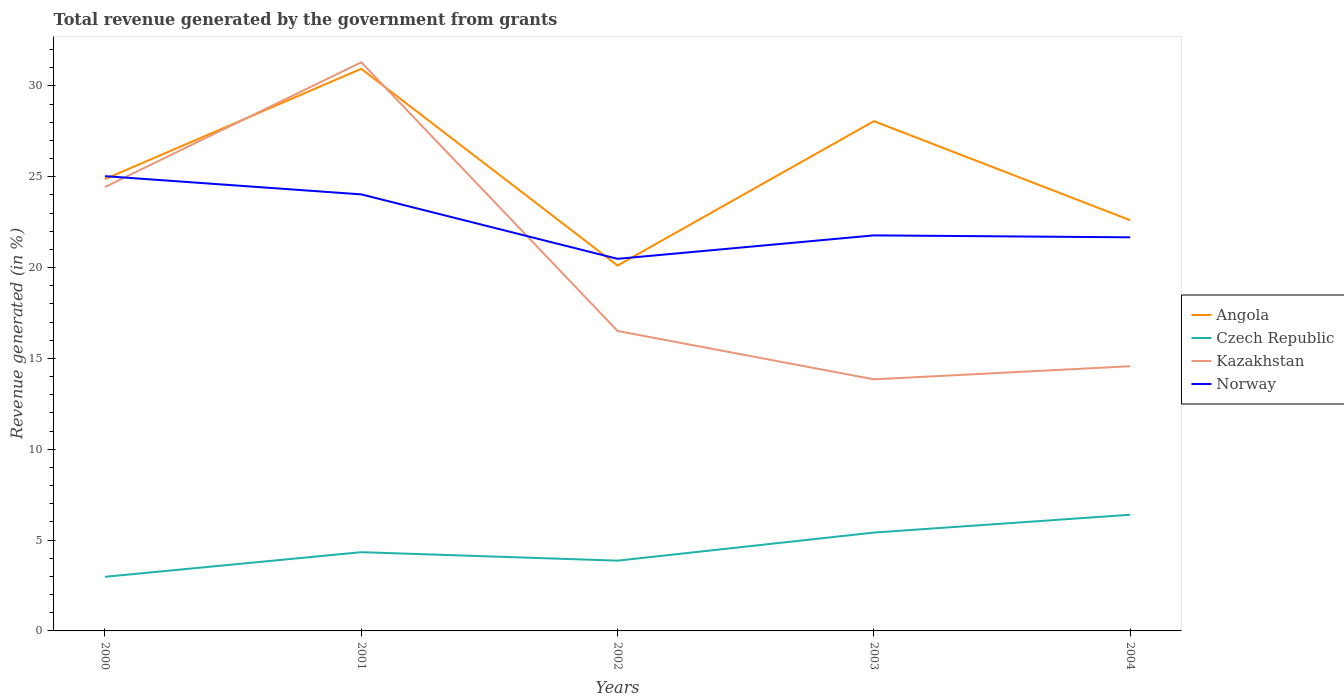How many different coloured lines are there?
Offer a terse response. 4. Does the line corresponding to Kazakhstan intersect with the line corresponding to Norway?
Offer a terse response. Yes. Across all years, what is the maximum total revenue generated in Czech Republic?
Your response must be concise. 2.98. What is the total total revenue generated in Norway in the graph?
Your answer should be compact. 2.26. What is the difference between the highest and the second highest total revenue generated in Czech Republic?
Keep it short and to the point. 3.41. Is the total revenue generated in Kazakhstan strictly greater than the total revenue generated in Angola over the years?
Provide a short and direct response. No. How many years are there in the graph?
Offer a very short reply. 5. Are the values on the major ticks of Y-axis written in scientific E-notation?
Your answer should be very brief. No. Does the graph contain any zero values?
Give a very brief answer. No. Does the graph contain grids?
Offer a terse response. No. How are the legend labels stacked?
Offer a terse response. Vertical. What is the title of the graph?
Your answer should be compact. Total revenue generated by the government from grants. Does "Iceland" appear as one of the legend labels in the graph?
Provide a short and direct response. No. What is the label or title of the Y-axis?
Provide a short and direct response. Revenue generated (in %). What is the Revenue generated (in %) in Angola in 2000?
Provide a succinct answer. 24.87. What is the Revenue generated (in %) of Czech Republic in 2000?
Give a very brief answer. 2.98. What is the Revenue generated (in %) of Kazakhstan in 2000?
Your answer should be compact. 24.43. What is the Revenue generated (in %) of Norway in 2000?
Keep it short and to the point. 25.03. What is the Revenue generated (in %) of Angola in 2001?
Your answer should be compact. 30.94. What is the Revenue generated (in %) of Czech Republic in 2001?
Make the answer very short. 4.33. What is the Revenue generated (in %) of Kazakhstan in 2001?
Ensure brevity in your answer.  31.3. What is the Revenue generated (in %) of Norway in 2001?
Your answer should be compact. 24.03. What is the Revenue generated (in %) of Angola in 2002?
Your answer should be very brief. 20.11. What is the Revenue generated (in %) of Czech Republic in 2002?
Offer a very short reply. 3.87. What is the Revenue generated (in %) in Kazakhstan in 2002?
Provide a short and direct response. 16.51. What is the Revenue generated (in %) in Norway in 2002?
Your answer should be compact. 20.48. What is the Revenue generated (in %) in Angola in 2003?
Provide a short and direct response. 28.06. What is the Revenue generated (in %) of Czech Republic in 2003?
Give a very brief answer. 5.41. What is the Revenue generated (in %) of Kazakhstan in 2003?
Make the answer very short. 13.85. What is the Revenue generated (in %) in Norway in 2003?
Keep it short and to the point. 21.77. What is the Revenue generated (in %) in Angola in 2004?
Provide a short and direct response. 22.61. What is the Revenue generated (in %) of Czech Republic in 2004?
Provide a succinct answer. 6.39. What is the Revenue generated (in %) in Kazakhstan in 2004?
Offer a very short reply. 14.57. What is the Revenue generated (in %) in Norway in 2004?
Provide a short and direct response. 21.66. Across all years, what is the maximum Revenue generated (in %) of Angola?
Provide a succinct answer. 30.94. Across all years, what is the maximum Revenue generated (in %) of Czech Republic?
Provide a short and direct response. 6.39. Across all years, what is the maximum Revenue generated (in %) of Kazakhstan?
Provide a succinct answer. 31.3. Across all years, what is the maximum Revenue generated (in %) in Norway?
Your answer should be very brief. 25.03. Across all years, what is the minimum Revenue generated (in %) in Angola?
Give a very brief answer. 20.11. Across all years, what is the minimum Revenue generated (in %) of Czech Republic?
Keep it short and to the point. 2.98. Across all years, what is the minimum Revenue generated (in %) of Kazakhstan?
Offer a terse response. 13.85. Across all years, what is the minimum Revenue generated (in %) of Norway?
Provide a short and direct response. 20.48. What is the total Revenue generated (in %) in Angola in the graph?
Make the answer very short. 126.58. What is the total Revenue generated (in %) in Czech Republic in the graph?
Your answer should be compact. 22.99. What is the total Revenue generated (in %) in Kazakhstan in the graph?
Your response must be concise. 100.65. What is the total Revenue generated (in %) in Norway in the graph?
Offer a terse response. 112.97. What is the difference between the Revenue generated (in %) of Angola in 2000 and that in 2001?
Give a very brief answer. -6.07. What is the difference between the Revenue generated (in %) in Czech Republic in 2000 and that in 2001?
Offer a very short reply. -1.36. What is the difference between the Revenue generated (in %) in Kazakhstan in 2000 and that in 2001?
Provide a short and direct response. -6.87. What is the difference between the Revenue generated (in %) of Norway in 2000 and that in 2001?
Offer a very short reply. 1. What is the difference between the Revenue generated (in %) in Angola in 2000 and that in 2002?
Ensure brevity in your answer.  4.76. What is the difference between the Revenue generated (in %) of Czech Republic in 2000 and that in 2002?
Ensure brevity in your answer.  -0.89. What is the difference between the Revenue generated (in %) of Kazakhstan in 2000 and that in 2002?
Offer a terse response. 7.92. What is the difference between the Revenue generated (in %) in Norway in 2000 and that in 2002?
Your answer should be very brief. 4.55. What is the difference between the Revenue generated (in %) of Angola in 2000 and that in 2003?
Provide a succinct answer. -3.19. What is the difference between the Revenue generated (in %) in Czech Republic in 2000 and that in 2003?
Keep it short and to the point. -2.43. What is the difference between the Revenue generated (in %) in Kazakhstan in 2000 and that in 2003?
Your response must be concise. 10.58. What is the difference between the Revenue generated (in %) of Norway in 2000 and that in 2003?
Your answer should be very brief. 3.26. What is the difference between the Revenue generated (in %) of Angola in 2000 and that in 2004?
Offer a terse response. 2.26. What is the difference between the Revenue generated (in %) in Czech Republic in 2000 and that in 2004?
Give a very brief answer. -3.41. What is the difference between the Revenue generated (in %) in Kazakhstan in 2000 and that in 2004?
Your answer should be compact. 9.86. What is the difference between the Revenue generated (in %) in Norway in 2000 and that in 2004?
Offer a very short reply. 3.37. What is the difference between the Revenue generated (in %) of Angola in 2001 and that in 2002?
Ensure brevity in your answer.  10.83. What is the difference between the Revenue generated (in %) of Czech Republic in 2001 and that in 2002?
Offer a very short reply. 0.47. What is the difference between the Revenue generated (in %) in Kazakhstan in 2001 and that in 2002?
Provide a succinct answer. 14.79. What is the difference between the Revenue generated (in %) in Norway in 2001 and that in 2002?
Give a very brief answer. 3.55. What is the difference between the Revenue generated (in %) in Angola in 2001 and that in 2003?
Offer a terse response. 2.88. What is the difference between the Revenue generated (in %) of Czech Republic in 2001 and that in 2003?
Make the answer very short. -1.08. What is the difference between the Revenue generated (in %) of Kazakhstan in 2001 and that in 2003?
Provide a succinct answer. 17.45. What is the difference between the Revenue generated (in %) in Norway in 2001 and that in 2003?
Your response must be concise. 2.26. What is the difference between the Revenue generated (in %) in Angola in 2001 and that in 2004?
Offer a very short reply. 8.33. What is the difference between the Revenue generated (in %) of Czech Republic in 2001 and that in 2004?
Your answer should be compact. -2.06. What is the difference between the Revenue generated (in %) of Kazakhstan in 2001 and that in 2004?
Your response must be concise. 16.73. What is the difference between the Revenue generated (in %) in Norway in 2001 and that in 2004?
Your response must be concise. 2.36. What is the difference between the Revenue generated (in %) in Angola in 2002 and that in 2003?
Ensure brevity in your answer.  -7.95. What is the difference between the Revenue generated (in %) in Czech Republic in 2002 and that in 2003?
Your answer should be compact. -1.55. What is the difference between the Revenue generated (in %) of Kazakhstan in 2002 and that in 2003?
Your response must be concise. 2.66. What is the difference between the Revenue generated (in %) in Norway in 2002 and that in 2003?
Provide a short and direct response. -1.29. What is the difference between the Revenue generated (in %) in Angola in 2002 and that in 2004?
Offer a very short reply. -2.5. What is the difference between the Revenue generated (in %) in Czech Republic in 2002 and that in 2004?
Make the answer very short. -2.53. What is the difference between the Revenue generated (in %) in Kazakhstan in 2002 and that in 2004?
Make the answer very short. 1.94. What is the difference between the Revenue generated (in %) of Norway in 2002 and that in 2004?
Offer a terse response. -1.18. What is the difference between the Revenue generated (in %) in Angola in 2003 and that in 2004?
Offer a very short reply. 5.45. What is the difference between the Revenue generated (in %) in Czech Republic in 2003 and that in 2004?
Keep it short and to the point. -0.98. What is the difference between the Revenue generated (in %) of Kazakhstan in 2003 and that in 2004?
Give a very brief answer. -0.72. What is the difference between the Revenue generated (in %) in Norway in 2003 and that in 2004?
Make the answer very short. 0.11. What is the difference between the Revenue generated (in %) of Angola in 2000 and the Revenue generated (in %) of Czech Republic in 2001?
Make the answer very short. 20.53. What is the difference between the Revenue generated (in %) in Angola in 2000 and the Revenue generated (in %) in Kazakhstan in 2001?
Provide a succinct answer. -6.43. What is the difference between the Revenue generated (in %) of Angola in 2000 and the Revenue generated (in %) of Norway in 2001?
Offer a terse response. 0.84. What is the difference between the Revenue generated (in %) in Czech Republic in 2000 and the Revenue generated (in %) in Kazakhstan in 2001?
Your response must be concise. -28.32. What is the difference between the Revenue generated (in %) of Czech Republic in 2000 and the Revenue generated (in %) of Norway in 2001?
Offer a very short reply. -21.05. What is the difference between the Revenue generated (in %) in Kazakhstan in 2000 and the Revenue generated (in %) in Norway in 2001?
Provide a succinct answer. 0.4. What is the difference between the Revenue generated (in %) of Angola in 2000 and the Revenue generated (in %) of Czech Republic in 2002?
Your response must be concise. 21. What is the difference between the Revenue generated (in %) in Angola in 2000 and the Revenue generated (in %) in Kazakhstan in 2002?
Provide a short and direct response. 8.36. What is the difference between the Revenue generated (in %) of Angola in 2000 and the Revenue generated (in %) of Norway in 2002?
Keep it short and to the point. 4.39. What is the difference between the Revenue generated (in %) in Czech Republic in 2000 and the Revenue generated (in %) in Kazakhstan in 2002?
Offer a very short reply. -13.53. What is the difference between the Revenue generated (in %) in Czech Republic in 2000 and the Revenue generated (in %) in Norway in 2002?
Provide a succinct answer. -17.5. What is the difference between the Revenue generated (in %) of Kazakhstan in 2000 and the Revenue generated (in %) of Norway in 2002?
Offer a very short reply. 3.95. What is the difference between the Revenue generated (in %) of Angola in 2000 and the Revenue generated (in %) of Czech Republic in 2003?
Your response must be concise. 19.46. What is the difference between the Revenue generated (in %) in Angola in 2000 and the Revenue generated (in %) in Kazakhstan in 2003?
Your answer should be very brief. 11.02. What is the difference between the Revenue generated (in %) of Angola in 2000 and the Revenue generated (in %) of Norway in 2003?
Offer a terse response. 3.1. What is the difference between the Revenue generated (in %) of Czech Republic in 2000 and the Revenue generated (in %) of Kazakhstan in 2003?
Your response must be concise. -10.87. What is the difference between the Revenue generated (in %) of Czech Republic in 2000 and the Revenue generated (in %) of Norway in 2003?
Offer a terse response. -18.79. What is the difference between the Revenue generated (in %) in Kazakhstan in 2000 and the Revenue generated (in %) in Norway in 2003?
Provide a short and direct response. 2.66. What is the difference between the Revenue generated (in %) in Angola in 2000 and the Revenue generated (in %) in Czech Republic in 2004?
Offer a very short reply. 18.48. What is the difference between the Revenue generated (in %) of Angola in 2000 and the Revenue generated (in %) of Kazakhstan in 2004?
Offer a terse response. 10.3. What is the difference between the Revenue generated (in %) of Angola in 2000 and the Revenue generated (in %) of Norway in 2004?
Your response must be concise. 3.21. What is the difference between the Revenue generated (in %) in Czech Republic in 2000 and the Revenue generated (in %) in Kazakhstan in 2004?
Make the answer very short. -11.59. What is the difference between the Revenue generated (in %) in Czech Republic in 2000 and the Revenue generated (in %) in Norway in 2004?
Make the answer very short. -18.68. What is the difference between the Revenue generated (in %) of Kazakhstan in 2000 and the Revenue generated (in %) of Norway in 2004?
Provide a succinct answer. 2.77. What is the difference between the Revenue generated (in %) in Angola in 2001 and the Revenue generated (in %) in Czech Republic in 2002?
Your answer should be compact. 27.07. What is the difference between the Revenue generated (in %) in Angola in 2001 and the Revenue generated (in %) in Kazakhstan in 2002?
Offer a terse response. 14.43. What is the difference between the Revenue generated (in %) in Angola in 2001 and the Revenue generated (in %) in Norway in 2002?
Your answer should be very brief. 10.46. What is the difference between the Revenue generated (in %) in Czech Republic in 2001 and the Revenue generated (in %) in Kazakhstan in 2002?
Offer a very short reply. -12.17. What is the difference between the Revenue generated (in %) in Czech Republic in 2001 and the Revenue generated (in %) in Norway in 2002?
Ensure brevity in your answer.  -16.14. What is the difference between the Revenue generated (in %) of Kazakhstan in 2001 and the Revenue generated (in %) of Norway in 2002?
Provide a short and direct response. 10.82. What is the difference between the Revenue generated (in %) of Angola in 2001 and the Revenue generated (in %) of Czech Republic in 2003?
Your answer should be very brief. 25.52. What is the difference between the Revenue generated (in %) of Angola in 2001 and the Revenue generated (in %) of Kazakhstan in 2003?
Provide a succinct answer. 17.09. What is the difference between the Revenue generated (in %) in Angola in 2001 and the Revenue generated (in %) in Norway in 2003?
Provide a short and direct response. 9.17. What is the difference between the Revenue generated (in %) in Czech Republic in 2001 and the Revenue generated (in %) in Kazakhstan in 2003?
Ensure brevity in your answer.  -9.51. What is the difference between the Revenue generated (in %) in Czech Republic in 2001 and the Revenue generated (in %) in Norway in 2003?
Your response must be concise. -17.44. What is the difference between the Revenue generated (in %) in Kazakhstan in 2001 and the Revenue generated (in %) in Norway in 2003?
Provide a short and direct response. 9.53. What is the difference between the Revenue generated (in %) in Angola in 2001 and the Revenue generated (in %) in Czech Republic in 2004?
Offer a terse response. 24.54. What is the difference between the Revenue generated (in %) in Angola in 2001 and the Revenue generated (in %) in Kazakhstan in 2004?
Provide a succinct answer. 16.37. What is the difference between the Revenue generated (in %) of Angola in 2001 and the Revenue generated (in %) of Norway in 2004?
Your response must be concise. 9.27. What is the difference between the Revenue generated (in %) of Czech Republic in 2001 and the Revenue generated (in %) of Kazakhstan in 2004?
Provide a succinct answer. -10.23. What is the difference between the Revenue generated (in %) in Czech Republic in 2001 and the Revenue generated (in %) in Norway in 2004?
Ensure brevity in your answer.  -17.33. What is the difference between the Revenue generated (in %) of Kazakhstan in 2001 and the Revenue generated (in %) of Norway in 2004?
Ensure brevity in your answer.  9.63. What is the difference between the Revenue generated (in %) in Angola in 2002 and the Revenue generated (in %) in Czech Republic in 2003?
Your answer should be compact. 14.7. What is the difference between the Revenue generated (in %) in Angola in 2002 and the Revenue generated (in %) in Kazakhstan in 2003?
Keep it short and to the point. 6.26. What is the difference between the Revenue generated (in %) of Angola in 2002 and the Revenue generated (in %) of Norway in 2003?
Ensure brevity in your answer.  -1.66. What is the difference between the Revenue generated (in %) in Czech Republic in 2002 and the Revenue generated (in %) in Kazakhstan in 2003?
Offer a terse response. -9.98. What is the difference between the Revenue generated (in %) of Czech Republic in 2002 and the Revenue generated (in %) of Norway in 2003?
Ensure brevity in your answer.  -17.9. What is the difference between the Revenue generated (in %) of Kazakhstan in 2002 and the Revenue generated (in %) of Norway in 2003?
Your response must be concise. -5.26. What is the difference between the Revenue generated (in %) of Angola in 2002 and the Revenue generated (in %) of Czech Republic in 2004?
Offer a terse response. 13.72. What is the difference between the Revenue generated (in %) of Angola in 2002 and the Revenue generated (in %) of Kazakhstan in 2004?
Make the answer very short. 5.54. What is the difference between the Revenue generated (in %) of Angola in 2002 and the Revenue generated (in %) of Norway in 2004?
Keep it short and to the point. -1.55. What is the difference between the Revenue generated (in %) of Czech Republic in 2002 and the Revenue generated (in %) of Kazakhstan in 2004?
Offer a very short reply. -10.7. What is the difference between the Revenue generated (in %) of Czech Republic in 2002 and the Revenue generated (in %) of Norway in 2004?
Offer a very short reply. -17.8. What is the difference between the Revenue generated (in %) in Kazakhstan in 2002 and the Revenue generated (in %) in Norway in 2004?
Provide a succinct answer. -5.16. What is the difference between the Revenue generated (in %) in Angola in 2003 and the Revenue generated (in %) in Czech Republic in 2004?
Make the answer very short. 21.66. What is the difference between the Revenue generated (in %) of Angola in 2003 and the Revenue generated (in %) of Kazakhstan in 2004?
Provide a succinct answer. 13.49. What is the difference between the Revenue generated (in %) of Angola in 2003 and the Revenue generated (in %) of Norway in 2004?
Your response must be concise. 6.39. What is the difference between the Revenue generated (in %) in Czech Republic in 2003 and the Revenue generated (in %) in Kazakhstan in 2004?
Your answer should be very brief. -9.15. What is the difference between the Revenue generated (in %) of Czech Republic in 2003 and the Revenue generated (in %) of Norway in 2004?
Give a very brief answer. -16.25. What is the difference between the Revenue generated (in %) in Kazakhstan in 2003 and the Revenue generated (in %) in Norway in 2004?
Your answer should be very brief. -7.82. What is the average Revenue generated (in %) of Angola per year?
Provide a short and direct response. 25.32. What is the average Revenue generated (in %) of Czech Republic per year?
Your answer should be compact. 4.6. What is the average Revenue generated (in %) of Kazakhstan per year?
Keep it short and to the point. 20.13. What is the average Revenue generated (in %) in Norway per year?
Your answer should be compact. 22.59. In the year 2000, what is the difference between the Revenue generated (in %) of Angola and Revenue generated (in %) of Czech Republic?
Ensure brevity in your answer.  21.89. In the year 2000, what is the difference between the Revenue generated (in %) in Angola and Revenue generated (in %) in Kazakhstan?
Your response must be concise. 0.44. In the year 2000, what is the difference between the Revenue generated (in %) of Angola and Revenue generated (in %) of Norway?
Provide a succinct answer. -0.16. In the year 2000, what is the difference between the Revenue generated (in %) of Czech Republic and Revenue generated (in %) of Kazakhstan?
Ensure brevity in your answer.  -21.45. In the year 2000, what is the difference between the Revenue generated (in %) of Czech Republic and Revenue generated (in %) of Norway?
Give a very brief answer. -22.05. In the year 2000, what is the difference between the Revenue generated (in %) in Kazakhstan and Revenue generated (in %) in Norway?
Provide a succinct answer. -0.6. In the year 2001, what is the difference between the Revenue generated (in %) in Angola and Revenue generated (in %) in Czech Republic?
Offer a very short reply. 26.6. In the year 2001, what is the difference between the Revenue generated (in %) of Angola and Revenue generated (in %) of Kazakhstan?
Keep it short and to the point. -0.36. In the year 2001, what is the difference between the Revenue generated (in %) of Angola and Revenue generated (in %) of Norway?
Give a very brief answer. 6.91. In the year 2001, what is the difference between the Revenue generated (in %) of Czech Republic and Revenue generated (in %) of Kazakhstan?
Offer a very short reply. -26.96. In the year 2001, what is the difference between the Revenue generated (in %) of Czech Republic and Revenue generated (in %) of Norway?
Ensure brevity in your answer.  -19.69. In the year 2001, what is the difference between the Revenue generated (in %) in Kazakhstan and Revenue generated (in %) in Norway?
Ensure brevity in your answer.  7.27. In the year 2002, what is the difference between the Revenue generated (in %) in Angola and Revenue generated (in %) in Czech Republic?
Give a very brief answer. 16.24. In the year 2002, what is the difference between the Revenue generated (in %) of Angola and Revenue generated (in %) of Kazakhstan?
Your response must be concise. 3.6. In the year 2002, what is the difference between the Revenue generated (in %) of Angola and Revenue generated (in %) of Norway?
Keep it short and to the point. -0.37. In the year 2002, what is the difference between the Revenue generated (in %) of Czech Republic and Revenue generated (in %) of Kazakhstan?
Provide a succinct answer. -12.64. In the year 2002, what is the difference between the Revenue generated (in %) of Czech Republic and Revenue generated (in %) of Norway?
Ensure brevity in your answer.  -16.61. In the year 2002, what is the difference between the Revenue generated (in %) of Kazakhstan and Revenue generated (in %) of Norway?
Keep it short and to the point. -3.97. In the year 2003, what is the difference between the Revenue generated (in %) of Angola and Revenue generated (in %) of Czech Republic?
Ensure brevity in your answer.  22.64. In the year 2003, what is the difference between the Revenue generated (in %) of Angola and Revenue generated (in %) of Kazakhstan?
Keep it short and to the point. 14.21. In the year 2003, what is the difference between the Revenue generated (in %) in Angola and Revenue generated (in %) in Norway?
Provide a short and direct response. 6.29. In the year 2003, what is the difference between the Revenue generated (in %) of Czech Republic and Revenue generated (in %) of Kazakhstan?
Offer a terse response. -8.43. In the year 2003, what is the difference between the Revenue generated (in %) of Czech Republic and Revenue generated (in %) of Norway?
Make the answer very short. -16.36. In the year 2003, what is the difference between the Revenue generated (in %) of Kazakhstan and Revenue generated (in %) of Norway?
Offer a terse response. -7.92. In the year 2004, what is the difference between the Revenue generated (in %) of Angola and Revenue generated (in %) of Czech Republic?
Offer a terse response. 16.21. In the year 2004, what is the difference between the Revenue generated (in %) in Angola and Revenue generated (in %) in Kazakhstan?
Give a very brief answer. 8.04. In the year 2004, what is the difference between the Revenue generated (in %) of Angola and Revenue generated (in %) of Norway?
Keep it short and to the point. 0.94. In the year 2004, what is the difference between the Revenue generated (in %) of Czech Republic and Revenue generated (in %) of Kazakhstan?
Keep it short and to the point. -8.17. In the year 2004, what is the difference between the Revenue generated (in %) of Czech Republic and Revenue generated (in %) of Norway?
Your response must be concise. -15.27. In the year 2004, what is the difference between the Revenue generated (in %) of Kazakhstan and Revenue generated (in %) of Norway?
Your answer should be compact. -7.1. What is the ratio of the Revenue generated (in %) of Angola in 2000 to that in 2001?
Offer a very short reply. 0.8. What is the ratio of the Revenue generated (in %) in Czech Republic in 2000 to that in 2001?
Your answer should be compact. 0.69. What is the ratio of the Revenue generated (in %) in Kazakhstan in 2000 to that in 2001?
Provide a short and direct response. 0.78. What is the ratio of the Revenue generated (in %) in Norway in 2000 to that in 2001?
Make the answer very short. 1.04. What is the ratio of the Revenue generated (in %) of Angola in 2000 to that in 2002?
Keep it short and to the point. 1.24. What is the ratio of the Revenue generated (in %) of Czech Republic in 2000 to that in 2002?
Offer a terse response. 0.77. What is the ratio of the Revenue generated (in %) in Kazakhstan in 2000 to that in 2002?
Your answer should be very brief. 1.48. What is the ratio of the Revenue generated (in %) of Norway in 2000 to that in 2002?
Provide a succinct answer. 1.22. What is the ratio of the Revenue generated (in %) in Angola in 2000 to that in 2003?
Offer a very short reply. 0.89. What is the ratio of the Revenue generated (in %) of Czech Republic in 2000 to that in 2003?
Offer a very short reply. 0.55. What is the ratio of the Revenue generated (in %) in Kazakhstan in 2000 to that in 2003?
Your answer should be very brief. 1.76. What is the ratio of the Revenue generated (in %) of Norway in 2000 to that in 2003?
Your answer should be compact. 1.15. What is the ratio of the Revenue generated (in %) in Angola in 2000 to that in 2004?
Make the answer very short. 1.1. What is the ratio of the Revenue generated (in %) of Czech Republic in 2000 to that in 2004?
Offer a very short reply. 0.47. What is the ratio of the Revenue generated (in %) of Kazakhstan in 2000 to that in 2004?
Offer a very short reply. 1.68. What is the ratio of the Revenue generated (in %) of Norway in 2000 to that in 2004?
Your response must be concise. 1.16. What is the ratio of the Revenue generated (in %) in Angola in 2001 to that in 2002?
Your answer should be compact. 1.54. What is the ratio of the Revenue generated (in %) of Czech Republic in 2001 to that in 2002?
Make the answer very short. 1.12. What is the ratio of the Revenue generated (in %) of Kazakhstan in 2001 to that in 2002?
Make the answer very short. 1.9. What is the ratio of the Revenue generated (in %) in Norway in 2001 to that in 2002?
Your response must be concise. 1.17. What is the ratio of the Revenue generated (in %) in Angola in 2001 to that in 2003?
Offer a very short reply. 1.1. What is the ratio of the Revenue generated (in %) in Czech Republic in 2001 to that in 2003?
Offer a terse response. 0.8. What is the ratio of the Revenue generated (in %) of Kazakhstan in 2001 to that in 2003?
Ensure brevity in your answer.  2.26. What is the ratio of the Revenue generated (in %) of Norway in 2001 to that in 2003?
Provide a short and direct response. 1.1. What is the ratio of the Revenue generated (in %) of Angola in 2001 to that in 2004?
Provide a succinct answer. 1.37. What is the ratio of the Revenue generated (in %) of Czech Republic in 2001 to that in 2004?
Provide a short and direct response. 0.68. What is the ratio of the Revenue generated (in %) of Kazakhstan in 2001 to that in 2004?
Offer a terse response. 2.15. What is the ratio of the Revenue generated (in %) in Norway in 2001 to that in 2004?
Your answer should be compact. 1.11. What is the ratio of the Revenue generated (in %) of Angola in 2002 to that in 2003?
Offer a very short reply. 0.72. What is the ratio of the Revenue generated (in %) of Czech Republic in 2002 to that in 2003?
Give a very brief answer. 0.71. What is the ratio of the Revenue generated (in %) of Kazakhstan in 2002 to that in 2003?
Provide a succinct answer. 1.19. What is the ratio of the Revenue generated (in %) of Norway in 2002 to that in 2003?
Provide a short and direct response. 0.94. What is the ratio of the Revenue generated (in %) of Angola in 2002 to that in 2004?
Give a very brief answer. 0.89. What is the ratio of the Revenue generated (in %) of Czech Republic in 2002 to that in 2004?
Give a very brief answer. 0.6. What is the ratio of the Revenue generated (in %) in Kazakhstan in 2002 to that in 2004?
Offer a very short reply. 1.13. What is the ratio of the Revenue generated (in %) in Norway in 2002 to that in 2004?
Give a very brief answer. 0.95. What is the ratio of the Revenue generated (in %) of Angola in 2003 to that in 2004?
Keep it short and to the point. 1.24. What is the ratio of the Revenue generated (in %) of Czech Republic in 2003 to that in 2004?
Your answer should be very brief. 0.85. What is the ratio of the Revenue generated (in %) in Kazakhstan in 2003 to that in 2004?
Your answer should be compact. 0.95. What is the ratio of the Revenue generated (in %) of Norway in 2003 to that in 2004?
Provide a short and direct response. 1. What is the difference between the highest and the second highest Revenue generated (in %) of Angola?
Keep it short and to the point. 2.88. What is the difference between the highest and the second highest Revenue generated (in %) in Czech Republic?
Give a very brief answer. 0.98. What is the difference between the highest and the second highest Revenue generated (in %) of Kazakhstan?
Your answer should be very brief. 6.87. What is the difference between the highest and the lowest Revenue generated (in %) in Angola?
Make the answer very short. 10.83. What is the difference between the highest and the lowest Revenue generated (in %) in Czech Republic?
Offer a very short reply. 3.41. What is the difference between the highest and the lowest Revenue generated (in %) in Kazakhstan?
Provide a succinct answer. 17.45. What is the difference between the highest and the lowest Revenue generated (in %) of Norway?
Offer a very short reply. 4.55. 